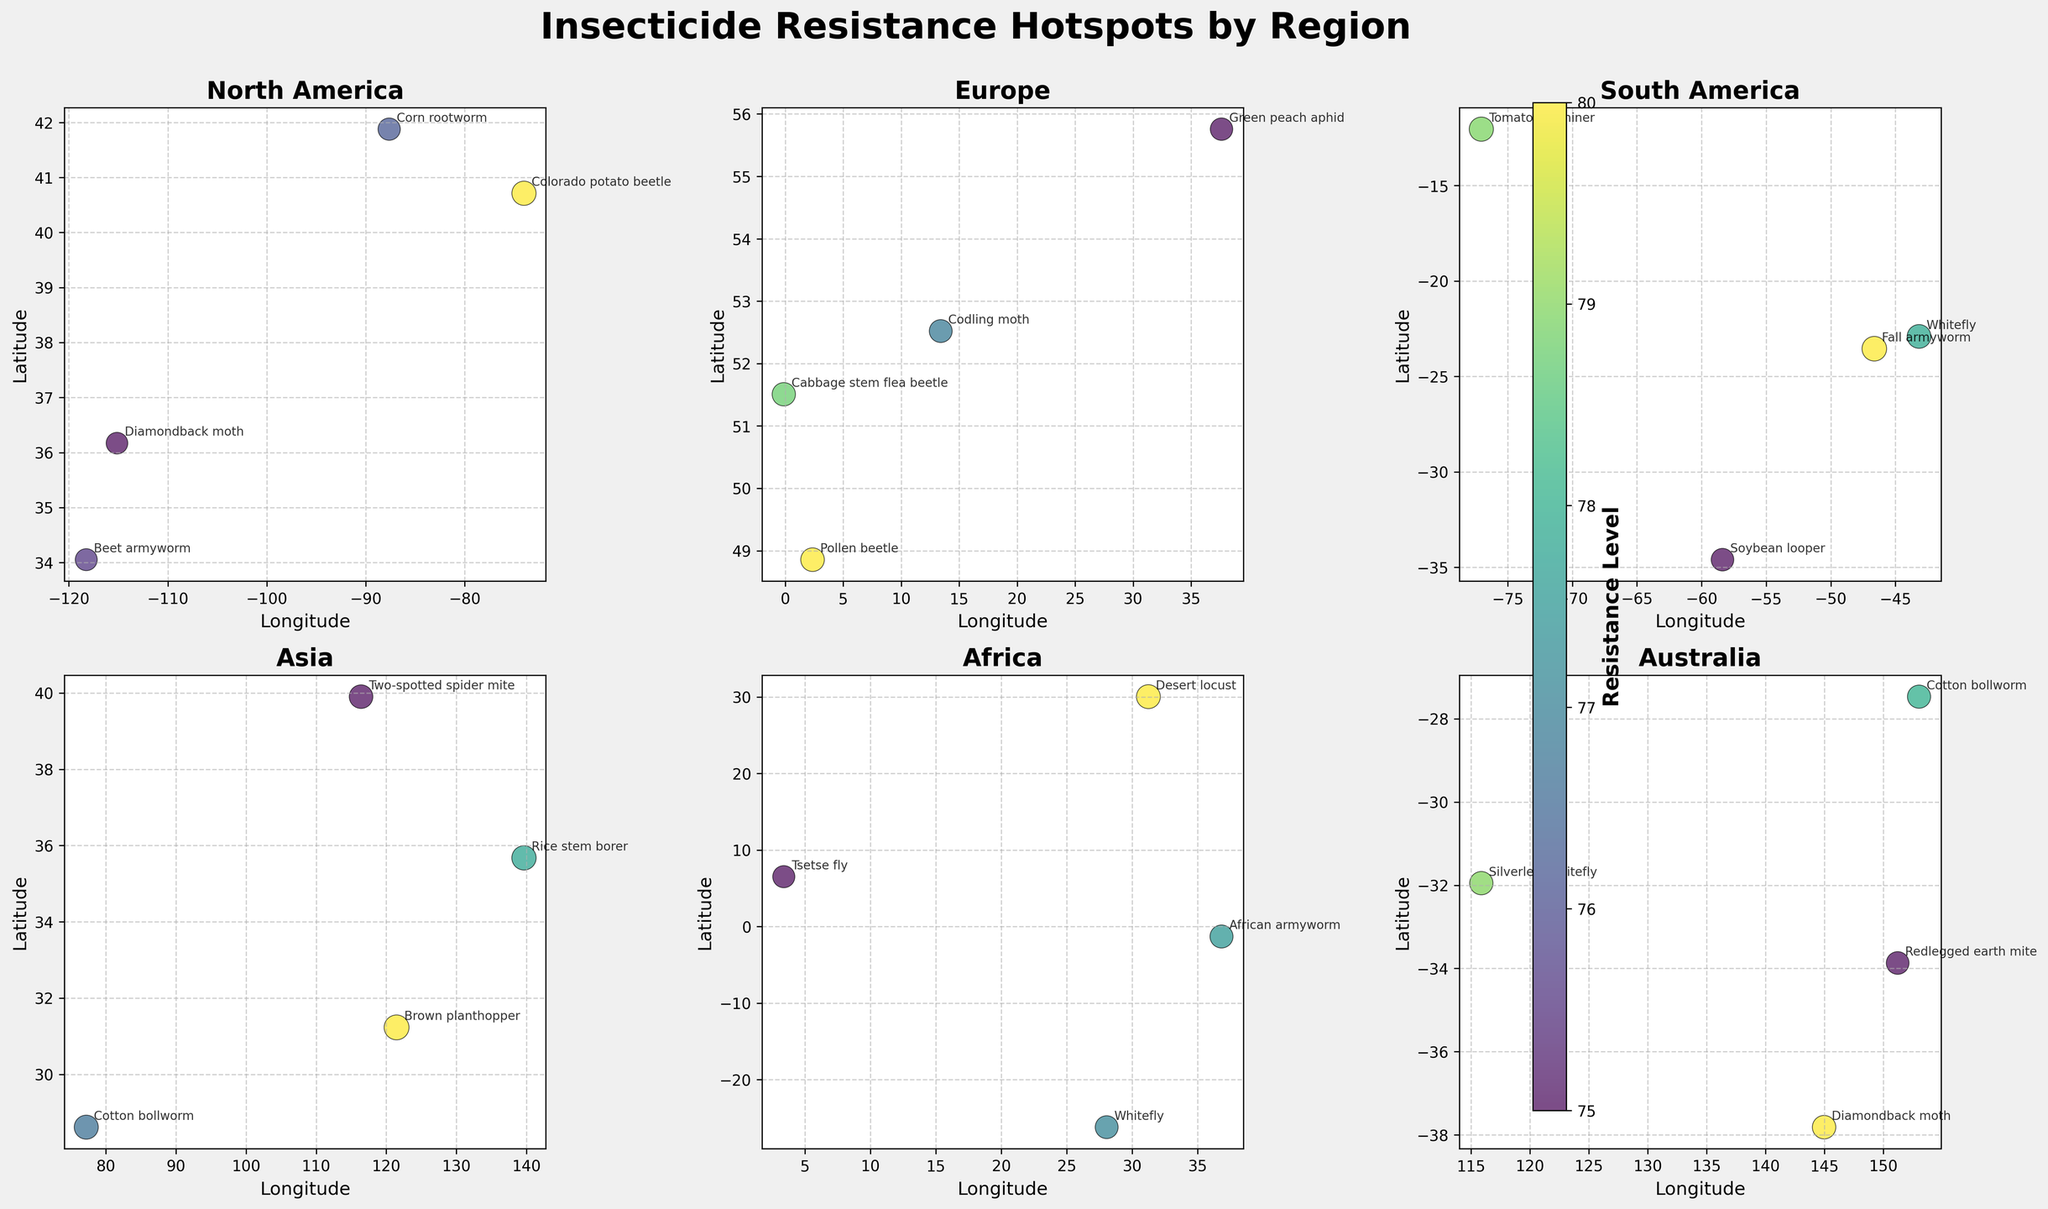Which region has the highest insecticide resistance level? Observe the color bar for resistance levels and compare the darkest points across regions. The darkest point represents the highest resistance. For Asia, the darkest point is brown planthopper. In other regions, resistance levels are slightly lower.
Answer: Asia Which pest in North America has the lowest resistance level? Look for the smallest dots in the North America subplot. The smallest dot with a label is beet armyworm.
Answer: Beet armyworm How do the resistance levels compare between the cotton bollworm in Asia and Australia? Cotton bollworm in Asia has a dot with color corresponding to resistance level 84, while in Australia, it corresponds to 78. Compare these values to determine that the resistance level in Asia is higher.
Answer: Higher in Asia What is the average resistance level for pests in Europe? Sum the resistance levels for Europe (79+81+76+73) and divide by the number of pests (4). The calculation is \( (79+81+76+73)/4 = 77.25 \).
Answer: 77.25 Which region has the most diverse pest types? Count the number of unique pests in each subplot. North America has 4 (Colorado potato beetle, Corn rootworm, Diamondback moth, Beet armyworm), Europe has 4 (Cabbage stem flea beetle, Pollen beetle, Codling moth, Green peach aphid), South America has 5, Asia has 4, Africa has 4, and Australia has 4. Hence, South America has the most diverse pest types.
Answer: South America 